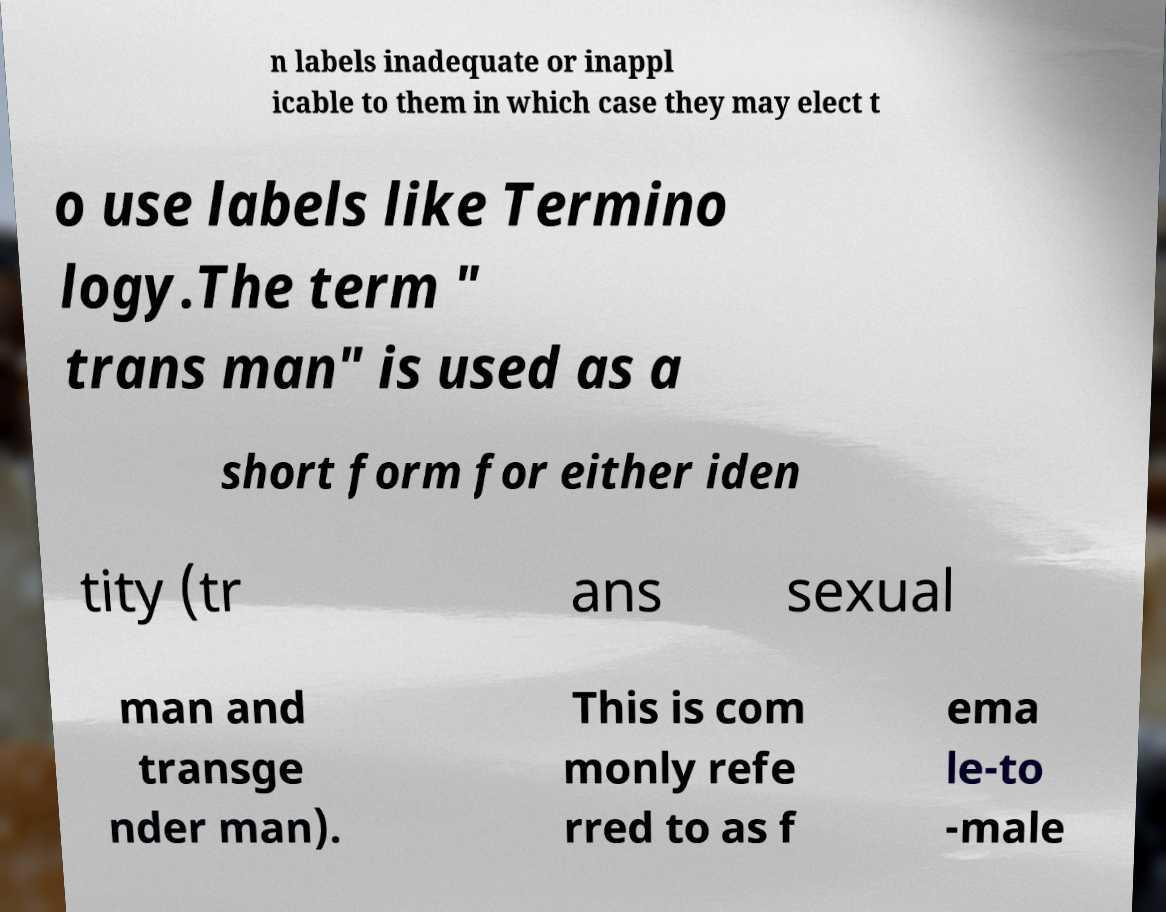There's text embedded in this image that I need extracted. Can you transcribe it verbatim? n labels inadequate or inappl icable to them in which case they may elect t o use labels like Termino logy.The term " trans man" is used as a short form for either iden tity (tr ans sexual man and transge nder man). This is com monly refe rred to as f ema le-to -male 